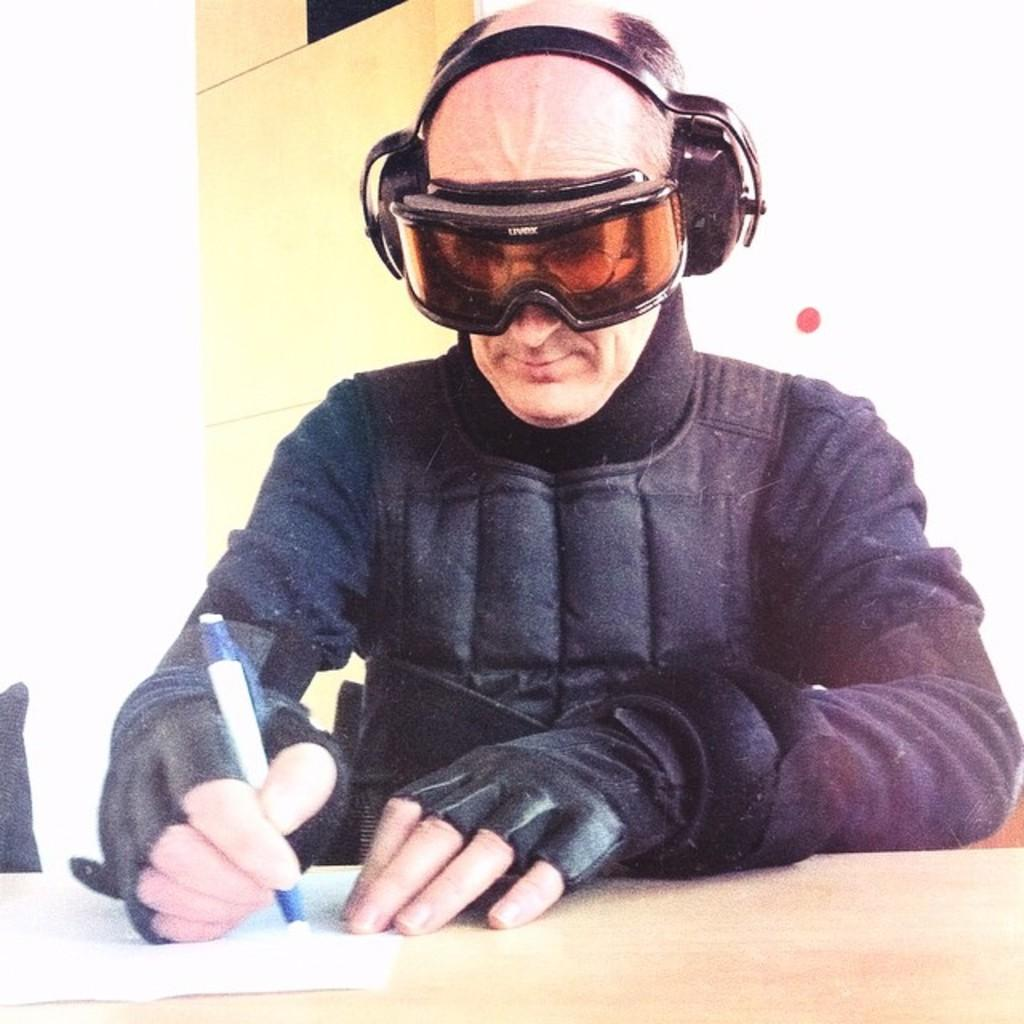Who is present in the image? There is a person in the image. What is the person holding in the image? The person is holding a pen. What is the person doing with the pen? The person is writing on a paper. Where is the paper located? The paper is on a table. What can be seen in the background of the image? There is a wall of a building in the background of the image. How does the zephyr affect the person's writing in the image? There is no mention of a zephyr in the image, so it cannot be determined how it would affect the person's writing. 